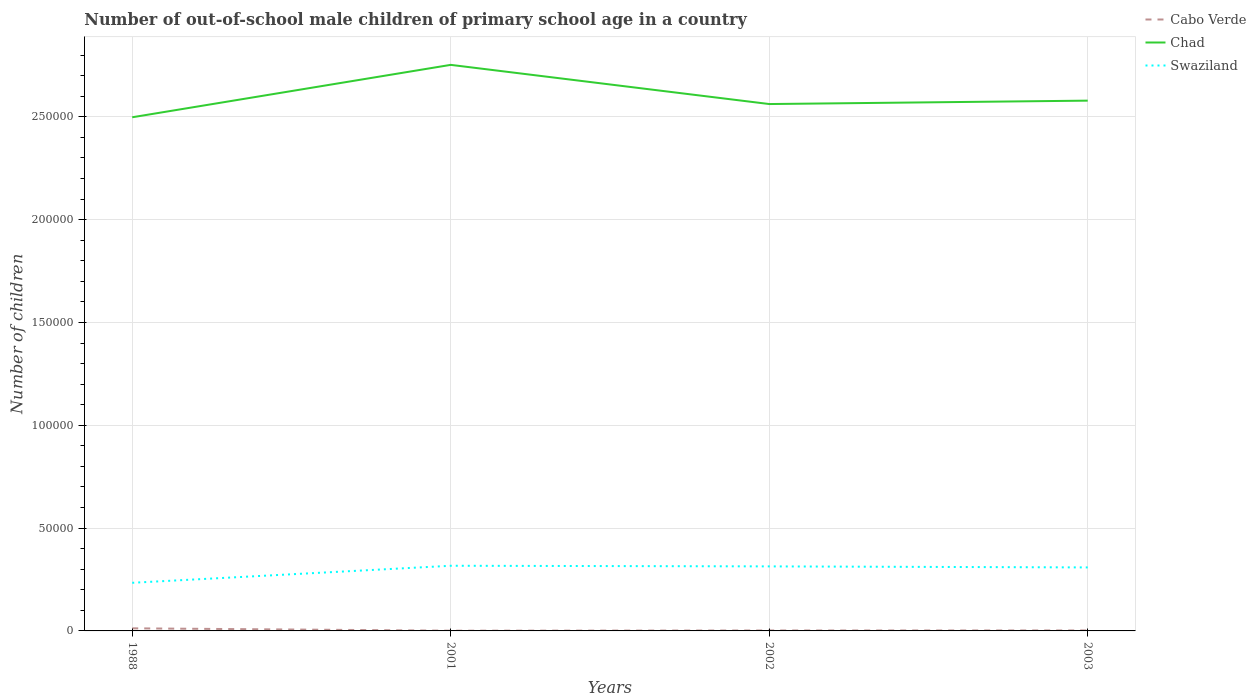Across all years, what is the maximum number of out-of-school male children in Swaziland?
Provide a succinct answer. 2.34e+04. What is the total number of out-of-school male children in Chad in the graph?
Your answer should be compact. -8085. What is the difference between the highest and the second highest number of out-of-school male children in Swaziland?
Offer a very short reply. 8282. Is the number of out-of-school male children in Chad strictly greater than the number of out-of-school male children in Cabo Verde over the years?
Offer a terse response. No. Where does the legend appear in the graph?
Give a very brief answer. Top right. What is the title of the graph?
Ensure brevity in your answer.  Number of out-of-school male children of primary school age in a country. What is the label or title of the Y-axis?
Give a very brief answer. Number of children. What is the Number of children in Cabo Verde in 1988?
Give a very brief answer. 1262. What is the Number of children in Chad in 1988?
Give a very brief answer. 2.50e+05. What is the Number of children of Swaziland in 1988?
Your answer should be very brief. 2.34e+04. What is the Number of children of Cabo Verde in 2001?
Your answer should be very brief. 109. What is the Number of children of Chad in 2001?
Offer a very short reply. 2.75e+05. What is the Number of children in Swaziland in 2001?
Your response must be concise. 3.17e+04. What is the Number of children of Cabo Verde in 2002?
Keep it short and to the point. 209. What is the Number of children of Chad in 2002?
Give a very brief answer. 2.56e+05. What is the Number of children of Swaziland in 2002?
Keep it short and to the point. 3.14e+04. What is the Number of children of Cabo Verde in 2003?
Your answer should be compact. 230. What is the Number of children of Chad in 2003?
Keep it short and to the point. 2.58e+05. What is the Number of children in Swaziland in 2003?
Provide a succinct answer. 3.09e+04. Across all years, what is the maximum Number of children of Cabo Verde?
Your response must be concise. 1262. Across all years, what is the maximum Number of children in Chad?
Offer a very short reply. 2.75e+05. Across all years, what is the maximum Number of children in Swaziland?
Provide a succinct answer. 3.17e+04. Across all years, what is the minimum Number of children in Cabo Verde?
Provide a short and direct response. 109. Across all years, what is the minimum Number of children in Chad?
Make the answer very short. 2.50e+05. Across all years, what is the minimum Number of children in Swaziland?
Your answer should be compact. 2.34e+04. What is the total Number of children in Cabo Verde in the graph?
Provide a short and direct response. 1810. What is the total Number of children of Chad in the graph?
Your response must be concise. 1.04e+06. What is the total Number of children in Swaziland in the graph?
Offer a terse response. 1.17e+05. What is the difference between the Number of children of Cabo Verde in 1988 and that in 2001?
Your answer should be compact. 1153. What is the difference between the Number of children in Chad in 1988 and that in 2001?
Your response must be concise. -2.55e+04. What is the difference between the Number of children in Swaziland in 1988 and that in 2001?
Provide a succinct answer. -8282. What is the difference between the Number of children of Cabo Verde in 1988 and that in 2002?
Offer a very short reply. 1053. What is the difference between the Number of children of Chad in 1988 and that in 2002?
Ensure brevity in your answer.  -6431. What is the difference between the Number of children in Swaziland in 1988 and that in 2002?
Your answer should be very brief. -7977. What is the difference between the Number of children in Cabo Verde in 1988 and that in 2003?
Provide a succinct answer. 1032. What is the difference between the Number of children in Chad in 1988 and that in 2003?
Your answer should be very brief. -8085. What is the difference between the Number of children in Swaziland in 1988 and that in 2003?
Provide a succinct answer. -7471. What is the difference between the Number of children in Cabo Verde in 2001 and that in 2002?
Your answer should be compact. -100. What is the difference between the Number of children in Chad in 2001 and that in 2002?
Offer a terse response. 1.90e+04. What is the difference between the Number of children in Swaziland in 2001 and that in 2002?
Provide a succinct answer. 305. What is the difference between the Number of children of Cabo Verde in 2001 and that in 2003?
Ensure brevity in your answer.  -121. What is the difference between the Number of children in Chad in 2001 and that in 2003?
Your response must be concise. 1.74e+04. What is the difference between the Number of children in Swaziland in 2001 and that in 2003?
Offer a very short reply. 811. What is the difference between the Number of children in Chad in 2002 and that in 2003?
Keep it short and to the point. -1654. What is the difference between the Number of children of Swaziland in 2002 and that in 2003?
Your response must be concise. 506. What is the difference between the Number of children of Cabo Verde in 1988 and the Number of children of Chad in 2001?
Ensure brevity in your answer.  -2.74e+05. What is the difference between the Number of children in Cabo Verde in 1988 and the Number of children in Swaziland in 2001?
Offer a terse response. -3.04e+04. What is the difference between the Number of children of Chad in 1988 and the Number of children of Swaziland in 2001?
Your answer should be very brief. 2.18e+05. What is the difference between the Number of children of Cabo Verde in 1988 and the Number of children of Chad in 2002?
Give a very brief answer. -2.55e+05. What is the difference between the Number of children of Cabo Verde in 1988 and the Number of children of Swaziland in 2002?
Your answer should be very brief. -3.01e+04. What is the difference between the Number of children of Chad in 1988 and the Number of children of Swaziland in 2002?
Offer a terse response. 2.18e+05. What is the difference between the Number of children of Cabo Verde in 1988 and the Number of children of Chad in 2003?
Your response must be concise. -2.57e+05. What is the difference between the Number of children in Cabo Verde in 1988 and the Number of children in Swaziland in 2003?
Your response must be concise. -2.96e+04. What is the difference between the Number of children of Chad in 1988 and the Number of children of Swaziland in 2003?
Provide a short and direct response. 2.19e+05. What is the difference between the Number of children in Cabo Verde in 2001 and the Number of children in Chad in 2002?
Your answer should be very brief. -2.56e+05. What is the difference between the Number of children in Cabo Verde in 2001 and the Number of children in Swaziland in 2002?
Ensure brevity in your answer.  -3.13e+04. What is the difference between the Number of children of Chad in 2001 and the Number of children of Swaziland in 2002?
Your response must be concise. 2.44e+05. What is the difference between the Number of children in Cabo Verde in 2001 and the Number of children in Chad in 2003?
Your answer should be very brief. -2.58e+05. What is the difference between the Number of children of Cabo Verde in 2001 and the Number of children of Swaziland in 2003?
Offer a very short reply. -3.08e+04. What is the difference between the Number of children of Chad in 2001 and the Number of children of Swaziland in 2003?
Ensure brevity in your answer.  2.44e+05. What is the difference between the Number of children of Cabo Verde in 2002 and the Number of children of Chad in 2003?
Offer a terse response. -2.58e+05. What is the difference between the Number of children in Cabo Verde in 2002 and the Number of children in Swaziland in 2003?
Keep it short and to the point. -3.07e+04. What is the difference between the Number of children of Chad in 2002 and the Number of children of Swaziland in 2003?
Give a very brief answer. 2.25e+05. What is the average Number of children in Cabo Verde per year?
Give a very brief answer. 452.5. What is the average Number of children of Chad per year?
Provide a succinct answer. 2.60e+05. What is the average Number of children in Swaziland per year?
Provide a succinct answer. 2.93e+04. In the year 1988, what is the difference between the Number of children of Cabo Verde and Number of children of Chad?
Keep it short and to the point. -2.49e+05. In the year 1988, what is the difference between the Number of children of Cabo Verde and Number of children of Swaziland?
Provide a succinct answer. -2.21e+04. In the year 1988, what is the difference between the Number of children of Chad and Number of children of Swaziland?
Your response must be concise. 2.26e+05. In the year 2001, what is the difference between the Number of children in Cabo Verde and Number of children in Chad?
Provide a succinct answer. -2.75e+05. In the year 2001, what is the difference between the Number of children in Cabo Verde and Number of children in Swaziland?
Offer a terse response. -3.16e+04. In the year 2001, what is the difference between the Number of children in Chad and Number of children in Swaziland?
Keep it short and to the point. 2.44e+05. In the year 2002, what is the difference between the Number of children of Cabo Verde and Number of children of Chad?
Provide a short and direct response. -2.56e+05. In the year 2002, what is the difference between the Number of children in Cabo Verde and Number of children in Swaziland?
Provide a short and direct response. -3.12e+04. In the year 2002, what is the difference between the Number of children of Chad and Number of children of Swaziland?
Offer a terse response. 2.25e+05. In the year 2003, what is the difference between the Number of children of Cabo Verde and Number of children of Chad?
Offer a terse response. -2.58e+05. In the year 2003, what is the difference between the Number of children in Cabo Verde and Number of children in Swaziland?
Your answer should be compact. -3.06e+04. In the year 2003, what is the difference between the Number of children in Chad and Number of children in Swaziland?
Your response must be concise. 2.27e+05. What is the ratio of the Number of children in Cabo Verde in 1988 to that in 2001?
Give a very brief answer. 11.58. What is the ratio of the Number of children of Chad in 1988 to that in 2001?
Keep it short and to the point. 0.91. What is the ratio of the Number of children in Swaziland in 1988 to that in 2001?
Offer a very short reply. 0.74. What is the ratio of the Number of children of Cabo Verde in 1988 to that in 2002?
Keep it short and to the point. 6.04. What is the ratio of the Number of children of Chad in 1988 to that in 2002?
Ensure brevity in your answer.  0.97. What is the ratio of the Number of children of Swaziland in 1988 to that in 2002?
Ensure brevity in your answer.  0.75. What is the ratio of the Number of children of Cabo Verde in 1988 to that in 2003?
Your response must be concise. 5.49. What is the ratio of the Number of children of Chad in 1988 to that in 2003?
Offer a very short reply. 0.97. What is the ratio of the Number of children of Swaziland in 1988 to that in 2003?
Your answer should be compact. 0.76. What is the ratio of the Number of children in Cabo Verde in 2001 to that in 2002?
Provide a short and direct response. 0.52. What is the ratio of the Number of children of Chad in 2001 to that in 2002?
Your response must be concise. 1.07. What is the ratio of the Number of children in Swaziland in 2001 to that in 2002?
Your answer should be very brief. 1.01. What is the ratio of the Number of children in Cabo Verde in 2001 to that in 2003?
Your answer should be very brief. 0.47. What is the ratio of the Number of children of Chad in 2001 to that in 2003?
Offer a very short reply. 1.07. What is the ratio of the Number of children in Swaziland in 2001 to that in 2003?
Your answer should be very brief. 1.03. What is the ratio of the Number of children of Cabo Verde in 2002 to that in 2003?
Your answer should be very brief. 0.91. What is the ratio of the Number of children of Chad in 2002 to that in 2003?
Offer a terse response. 0.99. What is the ratio of the Number of children of Swaziland in 2002 to that in 2003?
Keep it short and to the point. 1.02. What is the difference between the highest and the second highest Number of children in Cabo Verde?
Provide a short and direct response. 1032. What is the difference between the highest and the second highest Number of children in Chad?
Your response must be concise. 1.74e+04. What is the difference between the highest and the second highest Number of children in Swaziland?
Offer a terse response. 305. What is the difference between the highest and the lowest Number of children of Cabo Verde?
Give a very brief answer. 1153. What is the difference between the highest and the lowest Number of children of Chad?
Provide a short and direct response. 2.55e+04. What is the difference between the highest and the lowest Number of children of Swaziland?
Your response must be concise. 8282. 